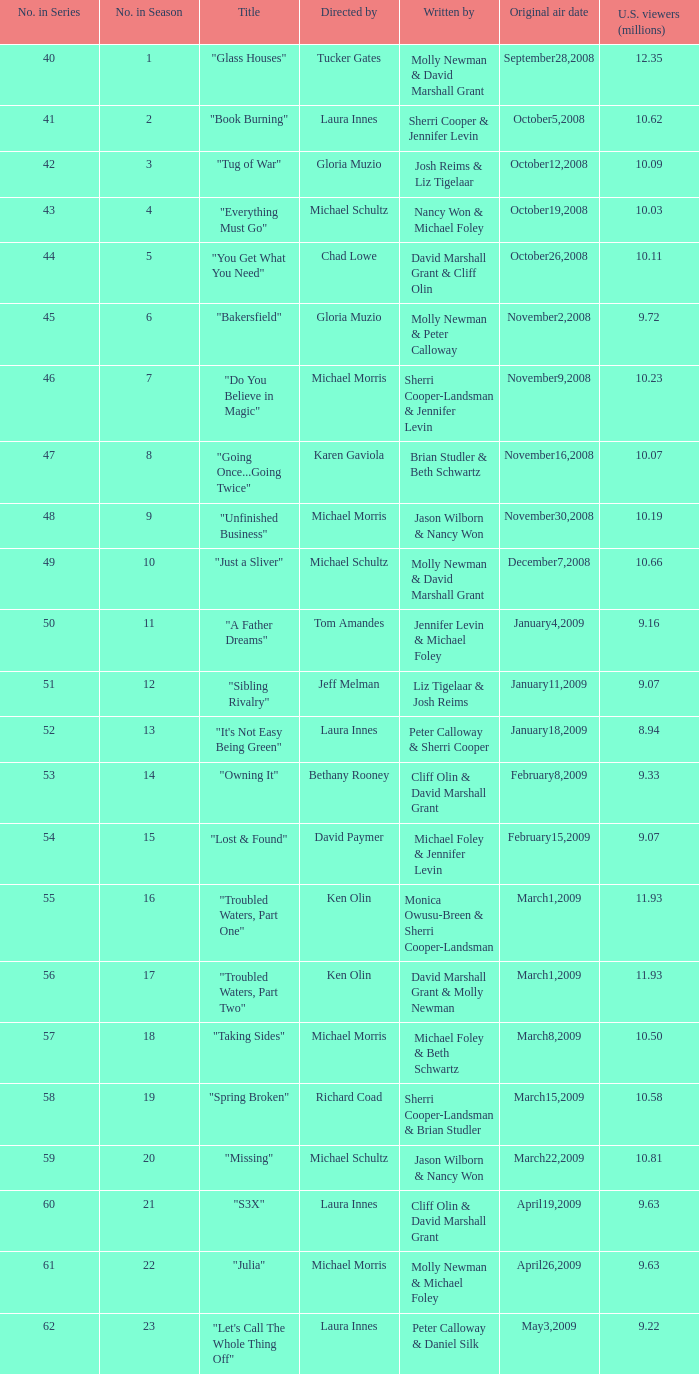Can you name the episode directed by laura innes that had 9.63 million viewers in the us? "S3X". 